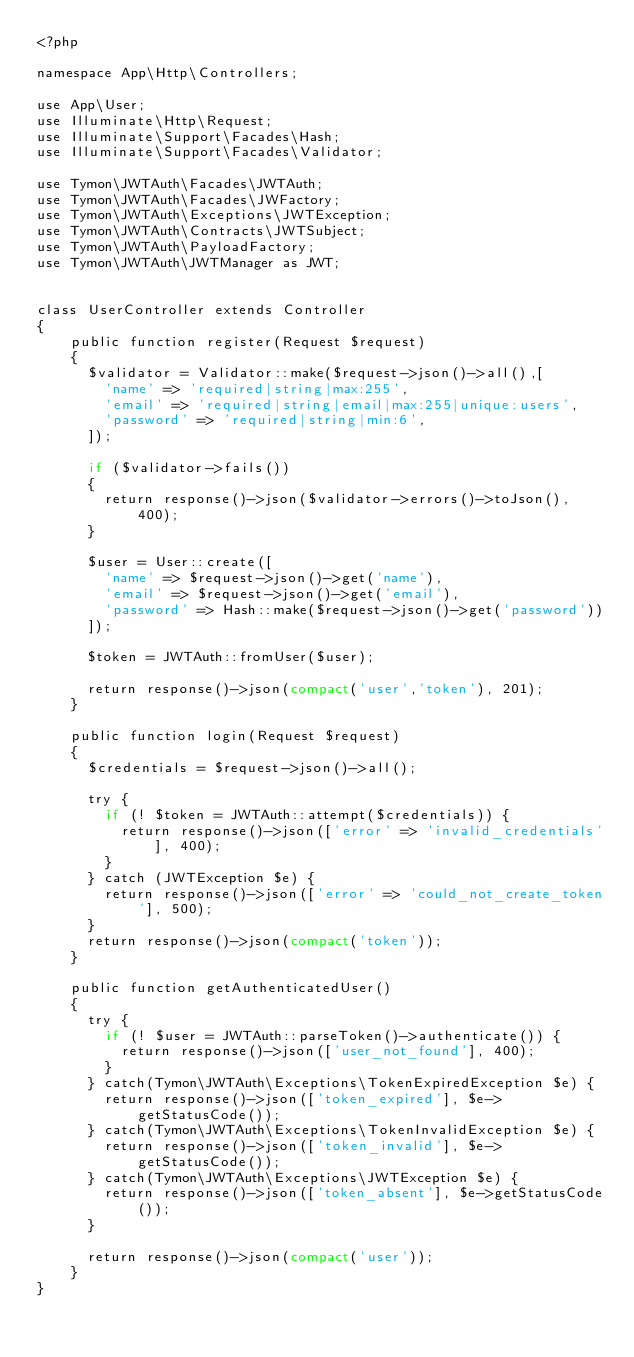<code> <loc_0><loc_0><loc_500><loc_500><_PHP_><?php

namespace App\Http\Controllers;

use App\User;
use Illuminate\Http\Request;
use Illuminate\Support\Facades\Hash;
use Illuminate\Support\Facades\Validator;

use Tymon\JWTAuth\Facades\JWTAuth;
use Tymon\JWTAuth\Facades\JWFactory;
use Tymon\JWTAuth\Exceptions\JWTException;
use Tymon\JWTAuth\Contracts\JWTSubject;
use Tymon\JWTAuth\PayloadFactory;
use Tymon\JWTAuth\JWTManager as JWT;


class UserController extends Controller
{
    public function register(Request $request)
    {
      $validator = Validator::make($request->json()->all(),[
        'name' => 'required|string|max:255',
        'email' => 'required|string|email|max:255|unique:users',
        'password' => 'required|string|min:6',
      ]);

      if ($validator->fails()) 
      {
        return response()->json($validator->errors()->toJson(), 400);
      }

      $user = User::create([
        'name' => $request->json()->get('name'),
        'email' => $request->json()->get('email'),
        'password' => Hash::make($request->json()->get('password'))
      ]);

      $token = JWTAuth::fromUser($user);

      return response()->json(compact('user','token'), 201);
    }

    public function login(Request $request)
    {
      $credentials = $request->json()->all();

      try {
        if (! $token = JWTAuth::attempt($credentials)) {
          return response()->json(['error' => 'invalid_credentials'], 400);
        }
      } catch (JWTException $e) {
        return response()->json(['error' => 'could_not_create_token'], 500);
      }
      return response()->json(compact('token'));
    }

    public function getAuthenticatedUser()
    {
      try {
        if (! $user = JWTAuth::parseToken()->authenticate()) {
          return response()->json(['user_not_found'], 400);
        }
      } catch(Tymon\JWTAuth\Exceptions\TokenExpiredException $e) {
        return response()->json(['token_expired'], $e->getStatusCode());
      } catch(Tymon\JWTAuth\Exceptions\TokenInvalidException $e) {
        return response()->json(['token_invalid'], $e->getStatusCode());
      } catch(Tymon\JWTAuth\Exceptions\JWTException $e) {
        return response()->json(['token_absent'], $e->getStatusCode());
      } 

      return response()->json(compact('user'));
    }
}
</code> 